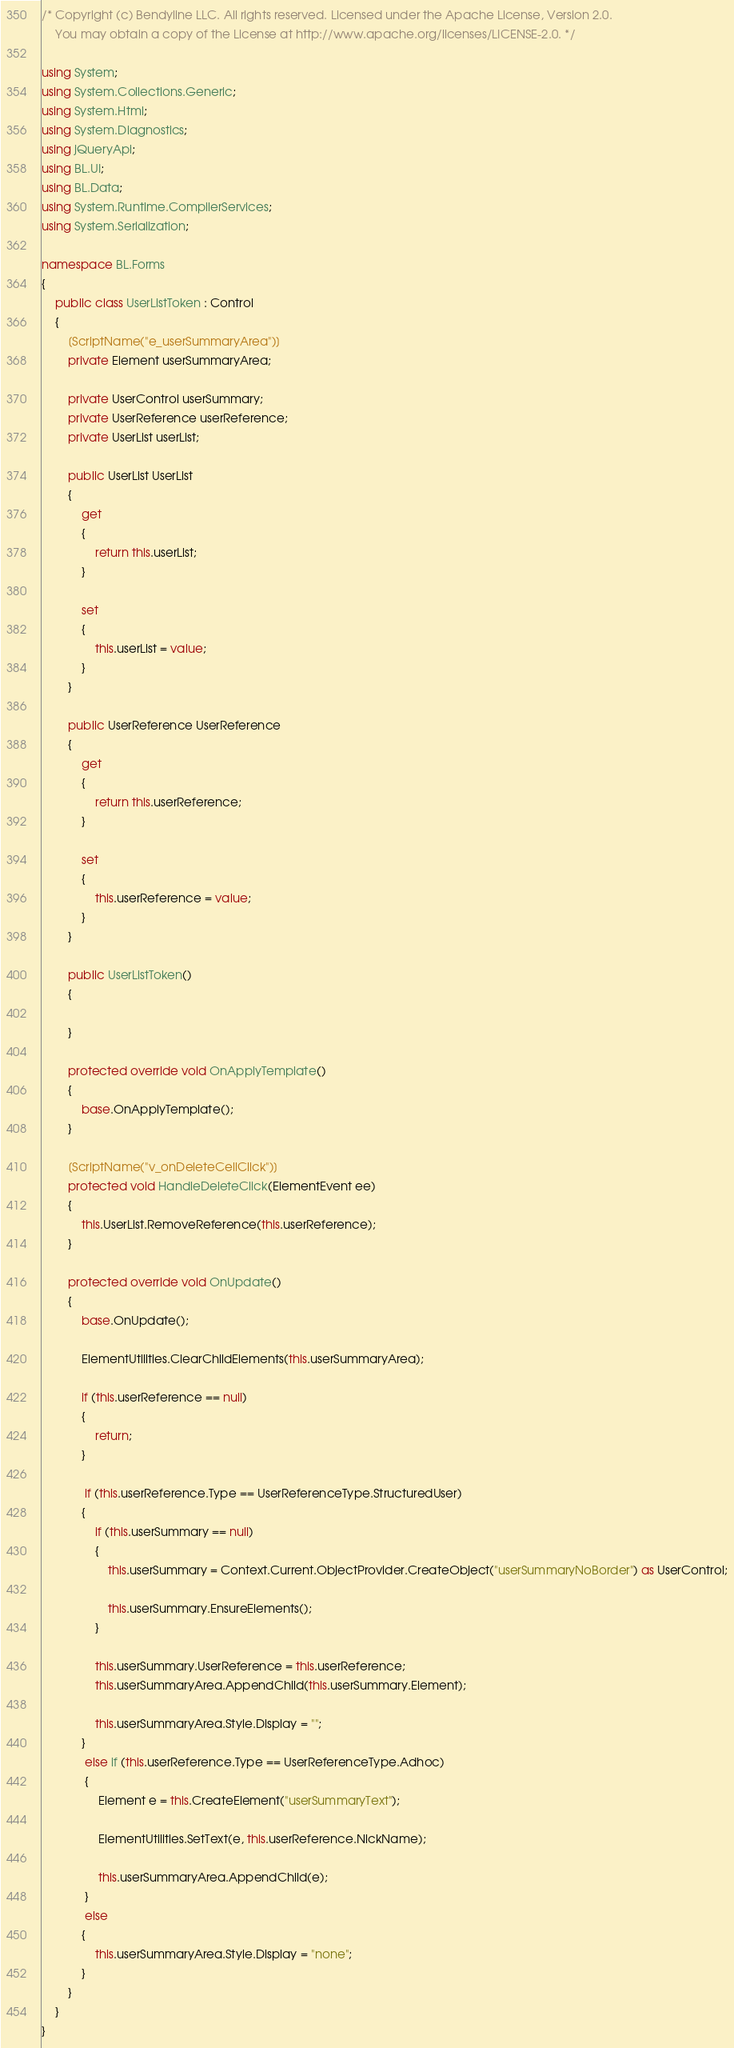Convert code to text. <code><loc_0><loc_0><loc_500><loc_500><_C#_>/* Copyright (c) Bendyline LLC. All rights reserved. Licensed under the Apache License, Version 2.0.
    You may obtain a copy of the License at http://www.apache.org/licenses/LICENSE-2.0. */

using System;
using System.Collections.Generic;
using System.Html;
using System.Diagnostics;
using jQueryApi;
using BL.UI;
using BL.Data;
using System.Runtime.CompilerServices;
using System.Serialization;

namespace BL.Forms
{
    public class UserListToken : Control
    {
        [ScriptName("e_userSummaryArea")]
        private Element userSummaryArea;

        private UserControl userSummary;
        private UserReference userReference;
        private UserList userList;

        public UserList UserList
        {
            get
            {
                return this.userList;
            }

            set
            {
                this.userList = value;
            }
        }

        public UserReference UserReference
        {
            get
            {
                return this.userReference;
            }

            set
            {
                this.userReference = value;
            }
        }
  
        public UserListToken()
        {

        }

        protected override void OnApplyTemplate()
        {
            base.OnApplyTemplate();
        }

        [ScriptName("v_onDeleteCellClick")]
        protected void HandleDeleteClick(ElementEvent ee)
        {
            this.UserList.RemoveReference(this.userReference);
        }

        protected override void OnUpdate()
        {
            base.OnUpdate();

            ElementUtilities.ClearChildElements(this.userSummaryArea);

            if (this.userReference == null)
            {
                return;
            }

             if (this.userReference.Type == UserReferenceType.StructuredUser)
            {
                if (this.userSummary == null)
                {
                    this.userSummary = Context.Current.ObjectProvider.CreateObject("userSummaryNoBorder") as UserControl;

                    this.userSummary.EnsureElements();
                }

                this.userSummary.UserReference = this.userReference;
                this.userSummaryArea.AppendChild(this.userSummary.Element);

                this.userSummaryArea.Style.Display = "";
            }
             else if (this.userReference.Type == UserReferenceType.Adhoc)
             {
                 Element e = this.CreateElement("userSummaryText");

                 ElementUtilities.SetText(e, this.userReference.NickName);

                 this.userSummaryArea.AppendChild(e);
             }
             else
            {
                this.userSummaryArea.Style.Display = "none";
            }
        }       
    }
}
</code> 